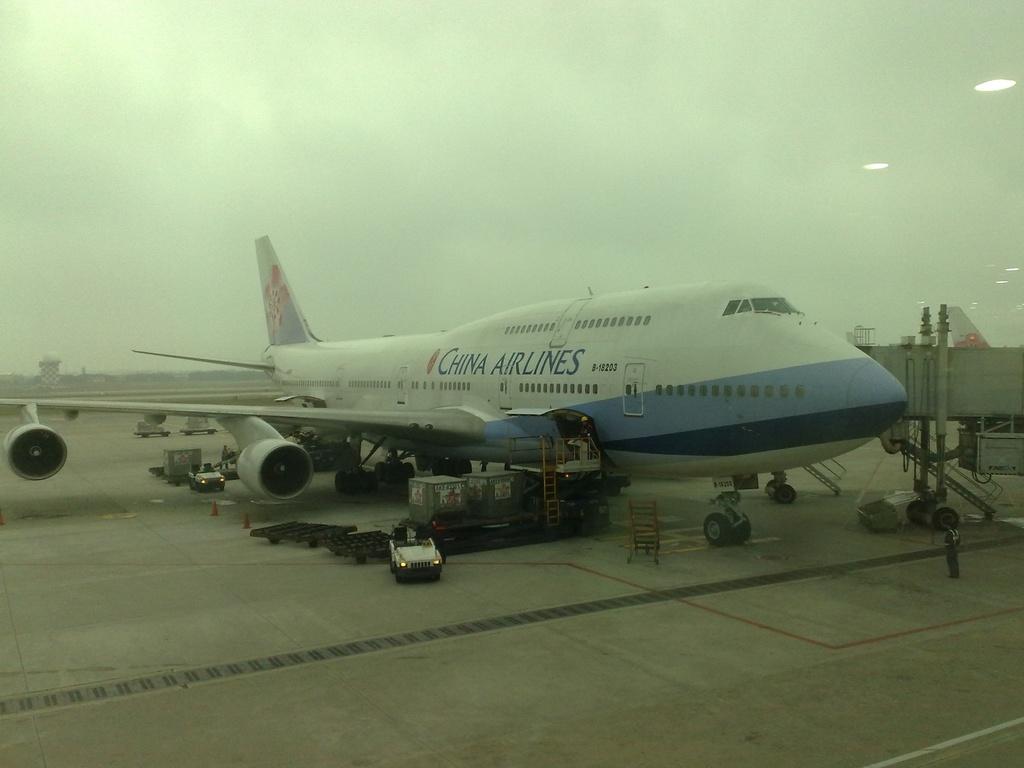What airline carrier is parked?
Ensure brevity in your answer.  China airlines. Does the plane's number end in 3?
Ensure brevity in your answer.  Yes. 